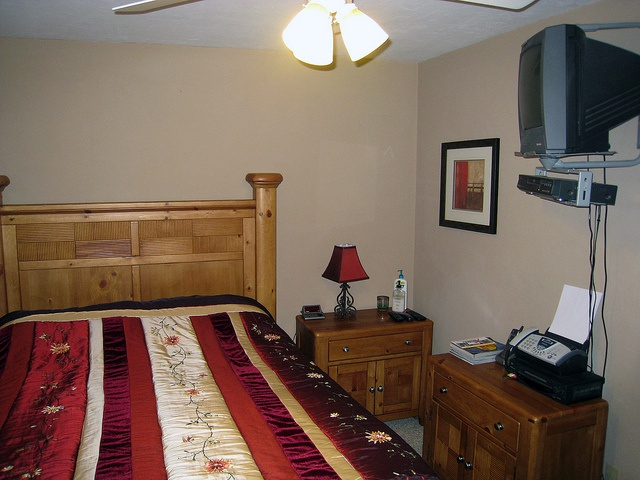Describe the objects in this image and their specific colors. I can see bed in gray, maroon, black, and brown tones, tv in gray, black, and purple tones, remote in black and gray tones, remote in gray and black tones, and remote in black and gray tones in this image. 